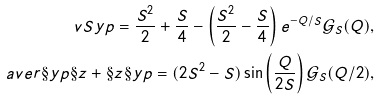Convert formula to latex. <formula><loc_0><loc_0><loc_500><loc_500>\ v S y p = \frac { S ^ { 2 } } { 2 } + \frac { S } { 4 } - \left ( \frac { S ^ { 2 } } { 2 } - \frac { S } { 4 } \right ) e ^ { - Q / S } \mathcal { G } _ { S } ( Q ) , \\ \ a v e r { \S y p \S z + \S z \S y p } = ( 2 S ^ { 2 } - S ) \sin \left ( \frac { Q } { 2 S } \right ) \mathcal { G } _ { S } ( Q / 2 ) ,</formula> 